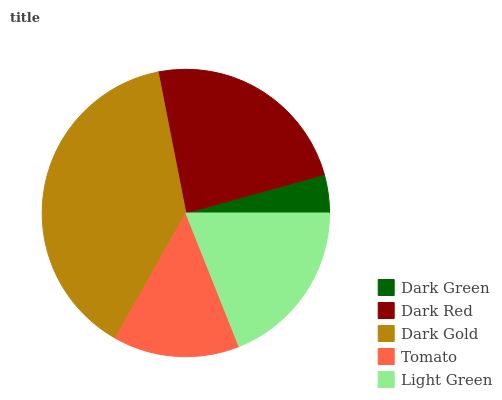Is Dark Green the minimum?
Answer yes or no. Yes. Is Dark Gold the maximum?
Answer yes or no. Yes. Is Dark Red the minimum?
Answer yes or no. No. Is Dark Red the maximum?
Answer yes or no. No. Is Dark Red greater than Dark Green?
Answer yes or no. Yes. Is Dark Green less than Dark Red?
Answer yes or no. Yes. Is Dark Green greater than Dark Red?
Answer yes or no. No. Is Dark Red less than Dark Green?
Answer yes or no. No. Is Light Green the high median?
Answer yes or no. Yes. Is Light Green the low median?
Answer yes or no. Yes. Is Dark Red the high median?
Answer yes or no. No. Is Dark Green the low median?
Answer yes or no. No. 